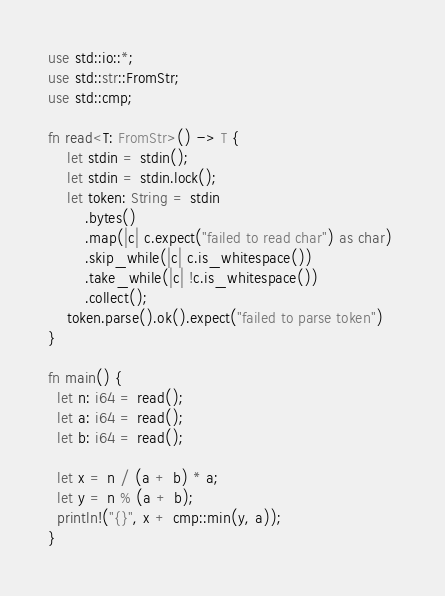Convert code to text. <code><loc_0><loc_0><loc_500><loc_500><_Rust_>use std::io::*;
use std::str::FromStr;
use std::cmp;

fn read<T: FromStr>() -> T {
    let stdin = stdin();
    let stdin = stdin.lock();
    let token: String = stdin
        .bytes()
        .map(|c| c.expect("failed to read char") as char) 
        .skip_while(|c| c.is_whitespace())
        .take_while(|c| !c.is_whitespace())
        .collect();
    token.parse().ok().expect("failed to parse token")
}

fn main() {
  let n: i64 = read();
  let a: i64 = read();
  let b: i64 = read();
  
  let x = n / (a + b) * a;
  let y = n % (a + b);
  println!("{}", x + cmp::min(y, a));
}</code> 